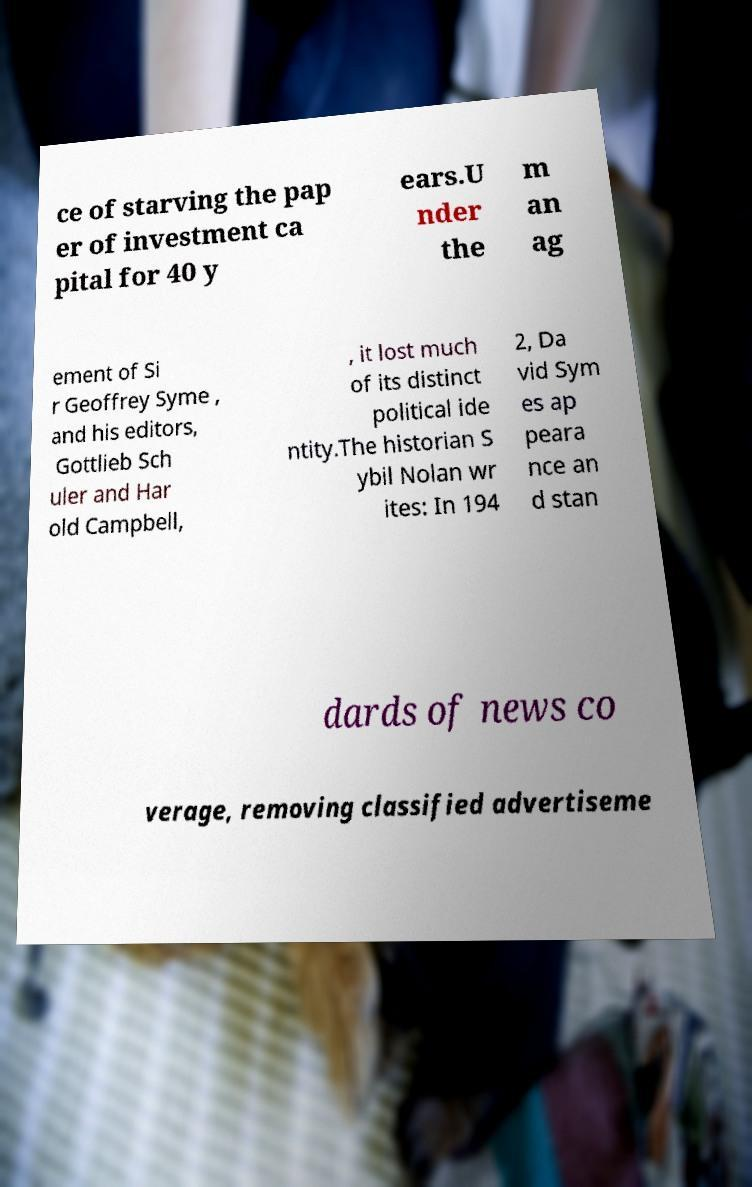Can you read and provide the text displayed in the image?This photo seems to have some interesting text. Can you extract and type it out for me? ce of starving the pap er of investment ca pital for 40 y ears.U nder the m an ag ement of Si r Geoffrey Syme , and his editors, Gottlieb Sch uler and Har old Campbell, , it lost much of its distinct political ide ntity.The historian S ybil Nolan wr ites: In 194 2, Da vid Sym es ap peara nce an d stan dards of news co verage, removing classified advertiseme 